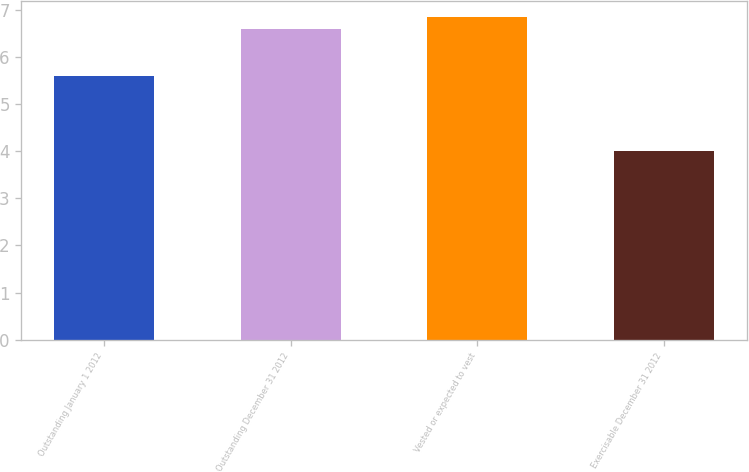Convert chart. <chart><loc_0><loc_0><loc_500><loc_500><bar_chart><fcel>Outstanding January 1 2012<fcel>Outstanding December 31 2012<fcel>Vested or expected to vest<fcel>Exercisable December 31 2012<nl><fcel>5.6<fcel>6.6<fcel>6.86<fcel>4<nl></chart> 